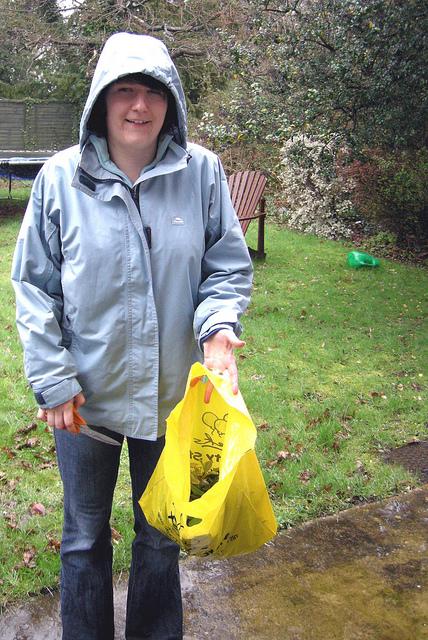Where is the bag?
Be succinct. In hand. Is she skinny?
Give a very brief answer. Yes. Is the weather rainy?
Short answer required. Yes. What color is the bag?
Keep it brief. Yellow. 